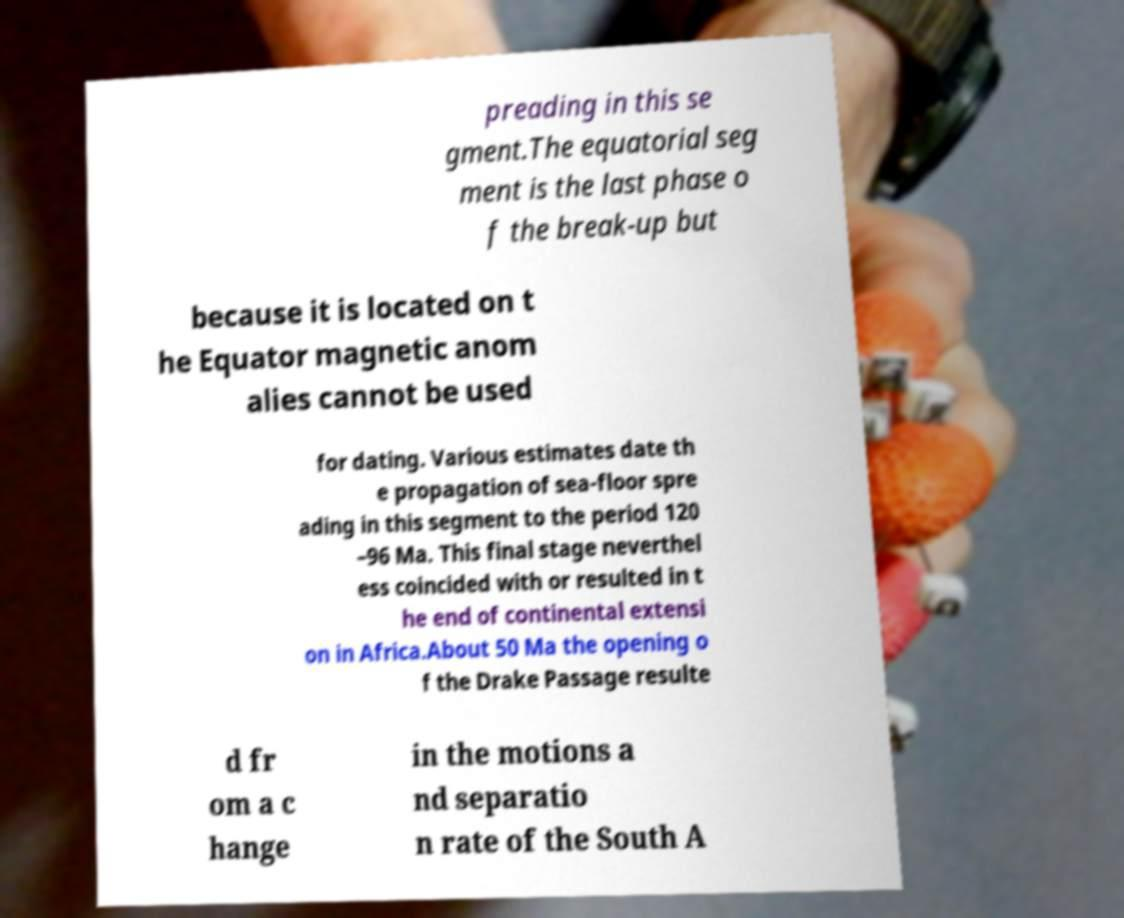Can you accurately transcribe the text from the provided image for me? preading in this se gment.The equatorial seg ment is the last phase o f the break-up but because it is located on t he Equator magnetic anom alies cannot be used for dating. Various estimates date th e propagation of sea-floor spre ading in this segment to the period 120 –96 Ma. This final stage neverthel ess coincided with or resulted in t he end of continental extensi on in Africa.About 50 Ma the opening o f the Drake Passage resulte d fr om a c hange in the motions a nd separatio n rate of the South A 